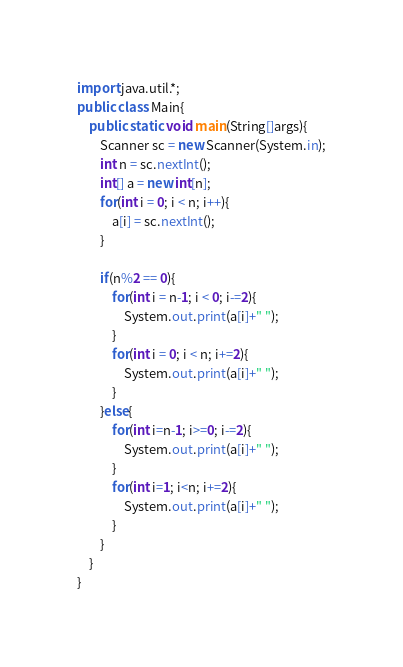Convert code to text. <code><loc_0><loc_0><loc_500><loc_500><_Java_>import java.util.*;
public class Main{
    public static void main(String[]args){
        Scanner sc = new Scanner(System.in);
        int n = sc.nextInt();
        int[] a = new int[n];
        for(int i = 0; i < n; i++){
            a[i] = sc.nextInt();
        }
        
        if(n%2 == 0){
            for(int i = n-1; i < 0; i-=2){
                System.out.print(a[i]+" ");
            }
            for(int i = 0; i < n; i+=2){
                System.out.print(a[i]+" ");
            }
        }else{
            for(int i=n-1; i>=0; i-=2){
                System.out.print(a[i]+" ");
            }
            for(int i=1; i<n; i+=2){
                System.out.print(a[i]+" ");
            }
        }
    }
}</code> 